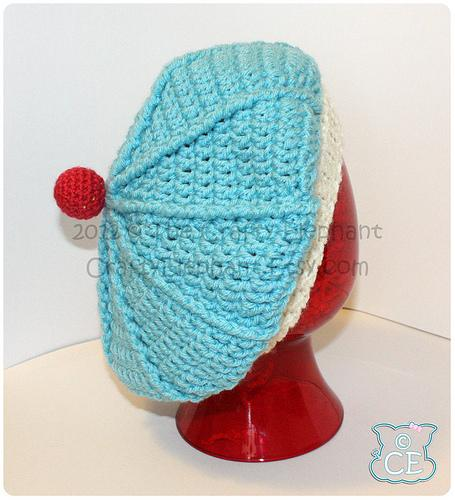Mention the most eye-catching object and its color in the image. A bright blue knitted hat with white and red accents steals the show, displayed on a red mannequin head. What is unique or noteworthy about the main subject in the image? The vivid blue crocheted hat with white borders and a red pom-pom on a red mannequin head stands out as a handmade item for sale on Etsy. Provide a brief description of the most prominent object in the image. A handmade blue and white crochet hat is displayed on a red transparent mannequin head. Write about the key elements you see, focusing on the centerpiece of the image. A striking blue crocheted hat with white accents and a red fluffy ball sits atop a red plastic mannequin head. Describe the primary object and its relation to the secondary object in the image. A prominently visible blue and white crochet hat sports a red detail on top, showcased on a red, translucent mannequin head. State the type of hat and its main attributes in the image. The image features a handcrafted blue crochet hat with white trim, red pom-pom, and distinctive pattern displayed on a red mannequin head. Mention the object that seems to be the largest in the image. A blue crocheted hat on a red mannequin head, occupying the largest area in the image. Explain the main focus of the image in a single sentence. The image highlights a handmade blue and white hat with a red pom-pom, exhibited on a transparent red mannequin head. Include the main object of the image and where it is positioned in a short description. A blue and white handmade hat positioned on a red transparent head-shaped mannequin, standing on a table. Describe the main features and colors of the hat presented in the image. A blue knitted hat with white trim and a red pom-pom on top is displayed on a red mannequin head. 